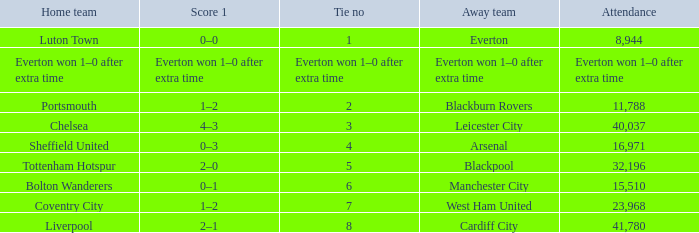What home team had an attendance record of 16,971? Sheffield United. 